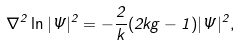Convert formula to latex. <formula><loc_0><loc_0><loc_500><loc_500>\nabla ^ { 2 } \ln | \Psi | ^ { 2 } = - \frac { 2 } { k } ( 2 k g - 1 ) | \Psi | ^ { 2 } ,</formula> 